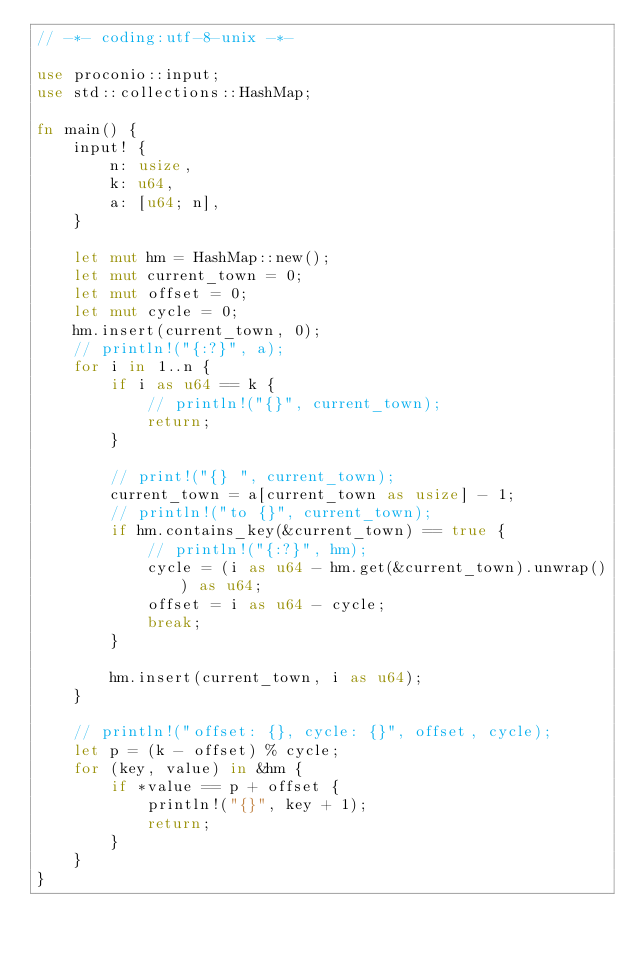<code> <loc_0><loc_0><loc_500><loc_500><_Rust_>// -*- coding:utf-8-unix -*-

use proconio::input;
use std::collections::HashMap;

fn main() {
    input! {
        n: usize,
        k: u64,
        a: [u64; n],
    }

    let mut hm = HashMap::new();
    let mut current_town = 0;
    let mut offset = 0;
    let mut cycle = 0;
    hm.insert(current_town, 0);
    // println!("{:?}", a);
    for i in 1..n {
        if i as u64 == k {
            // println!("{}", current_town);
            return;
        }

        // print!("{} ", current_town);
        current_town = a[current_town as usize] - 1;
        // println!("to {}", current_town);
        if hm.contains_key(&current_town) == true {
            // println!("{:?}", hm);
            cycle = (i as u64 - hm.get(&current_town).unwrap()) as u64;
            offset = i as u64 - cycle;
            break;
        }

        hm.insert(current_town, i as u64);
    }

    // println!("offset: {}, cycle: {}", offset, cycle);
    let p = (k - offset) % cycle;
    for (key, value) in &hm {
        if *value == p + offset {
            println!("{}", key + 1);
            return;
        }
    }
}
</code> 